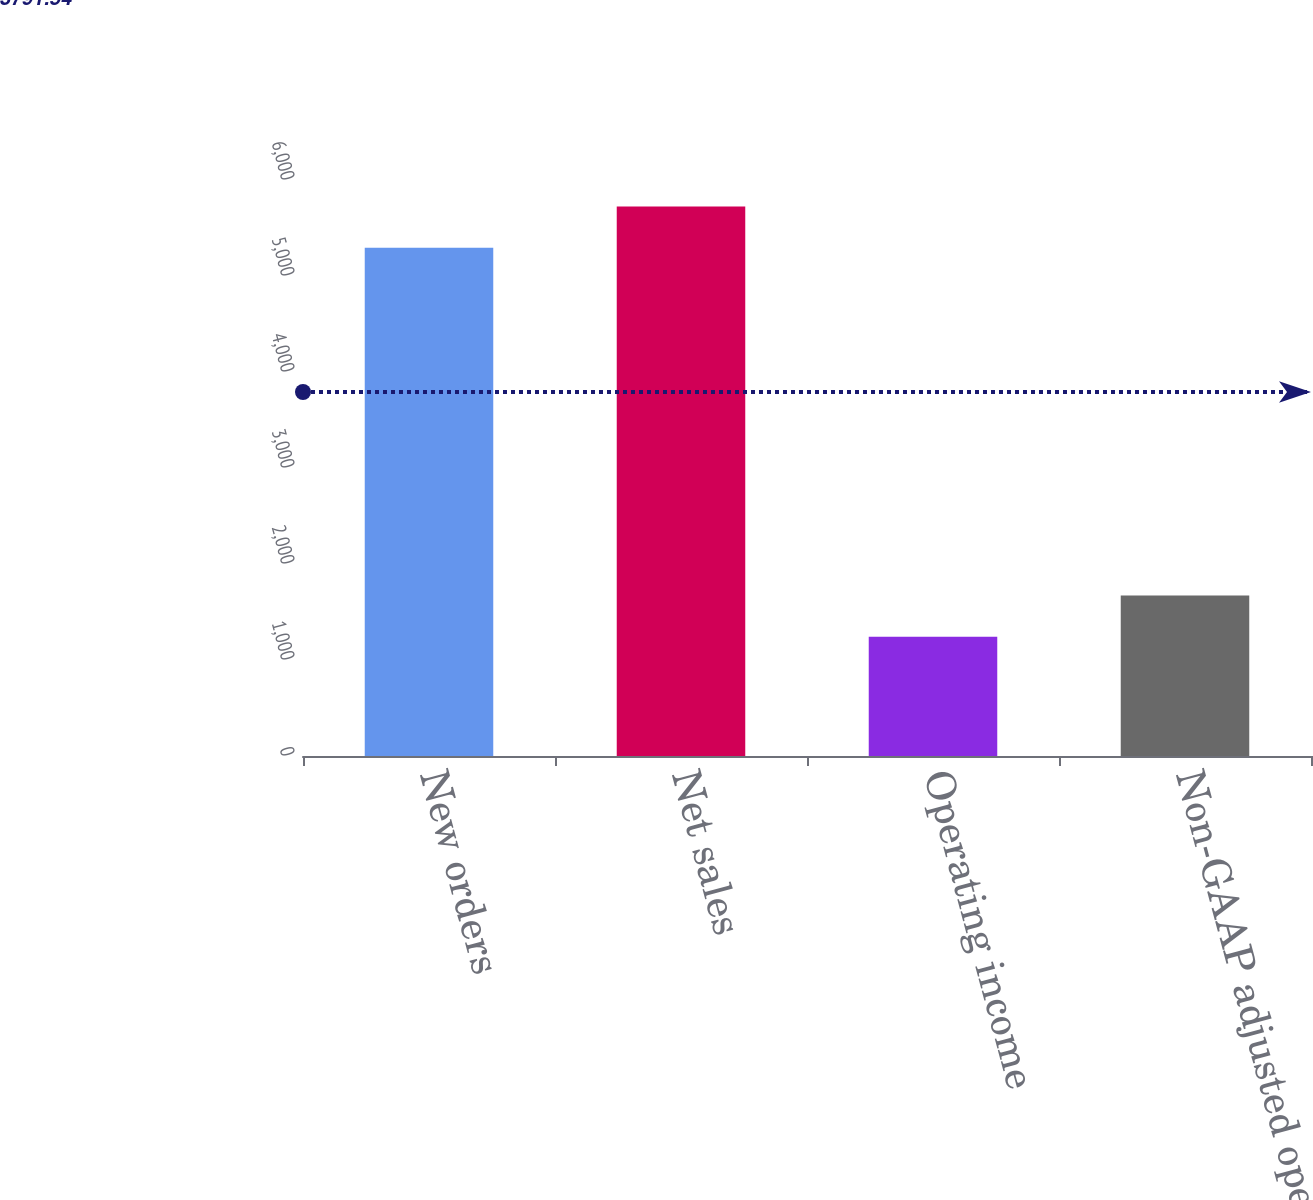<chart> <loc_0><loc_0><loc_500><loc_500><bar_chart><fcel>New orders<fcel>Net sales<fcel>Operating income<fcel>Non-GAAP adjusted operating<nl><fcel>5294<fcel>5723.3<fcel>1243<fcel>1672.3<nl></chart> 